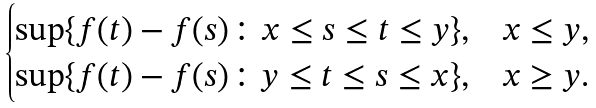Convert formula to latex. <formula><loc_0><loc_0><loc_500><loc_500>\begin{cases} \sup \{ f ( t ) - f ( s ) \colon x \leq s \leq t \leq y \} , & x \leq y , \\ \sup \{ f ( t ) - f ( s ) \colon y \leq t \leq s \leq x \} , & x \geq y . \end{cases}</formula> 